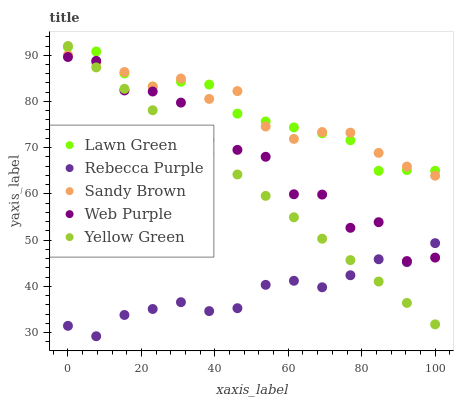Does Rebecca Purple have the minimum area under the curve?
Answer yes or no. Yes. Does Sandy Brown have the maximum area under the curve?
Answer yes or no. Yes. Does Web Purple have the minimum area under the curve?
Answer yes or no. No. Does Web Purple have the maximum area under the curve?
Answer yes or no. No. Is Yellow Green the smoothest?
Answer yes or no. Yes. Is Web Purple the roughest?
Answer yes or no. Yes. Is Sandy Brown the smoothest?
Answer yes or no. No. Is Sandy Brown the roughest?
Answer yes or no. No. Does Rebecca Purple have the lowest value?
Answer yes or no. Yes. Does Web Purple have the lowest value?
Answer yes or no. No. Does Yellow Green have the highest value?
Answer yes or no. Yes. Does Web Purple have the highest value?
Answer yes or no. No. Is Web Purple less than Lawn Green?
Answer yes or no. Yes. Is Sandy Brown greater than Rebecca Purple?
Answer yes or no. Yes. Does Rebecca Purple intersect Web Purple?
Answer yes or no. Yes. Is Rebecca Purple less than Web Purple?
Answer yes or no. No. Is Rebecca Purple greater than Web Purple?
Answer yes or no. No. Does Web Purple intersect Lawn Green?
Answer yes or no. No. 